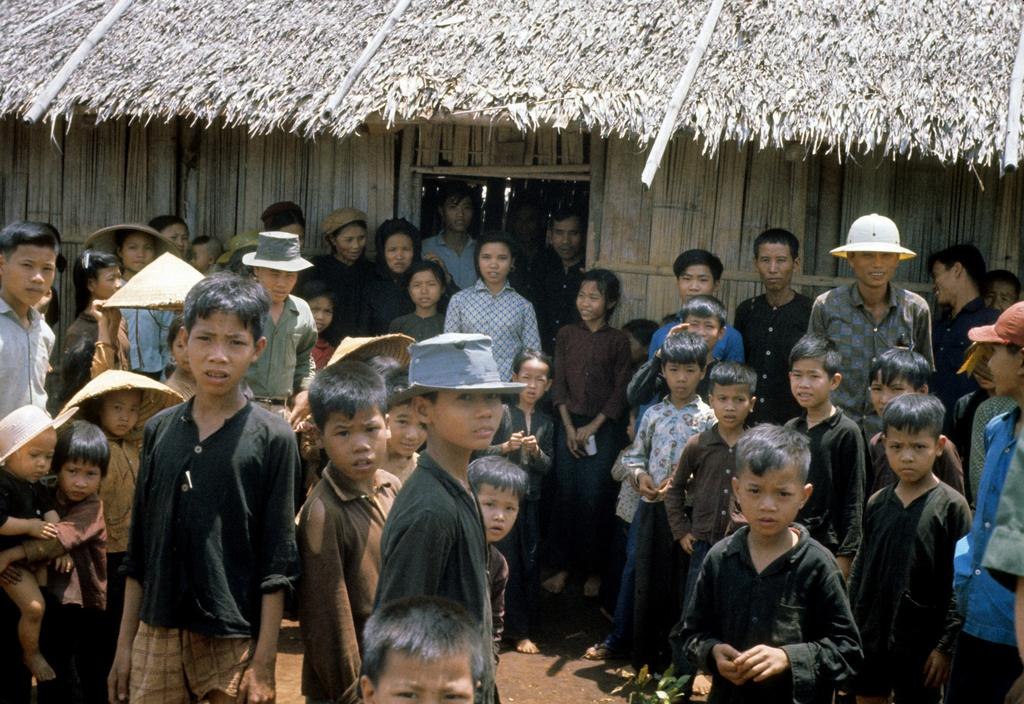How many people are in the image? There is a group of people in the image, but the exact number is not specified. What are the people doing in the image? The people are on the ground, but their specific activity is not mentioned. What can be seen in the background of the image? There is a hut in the background of the image. What type of alarm is ringing in the image? There is no alarm present in the image. How many carts are visible in the image? There is no mention of carts in the image. What is the credit score of the person in the image? There is no information about a person's credit score in the image. 